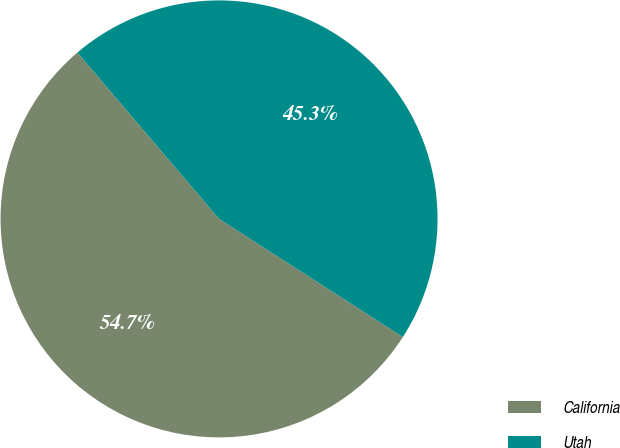<chart> <loc_0><loc_0><loc_500><loc_500><pie_chart><fcel>California<fcel>Utah<nl><fcel>54.68%<fcel>45.32%<nl></chart> 